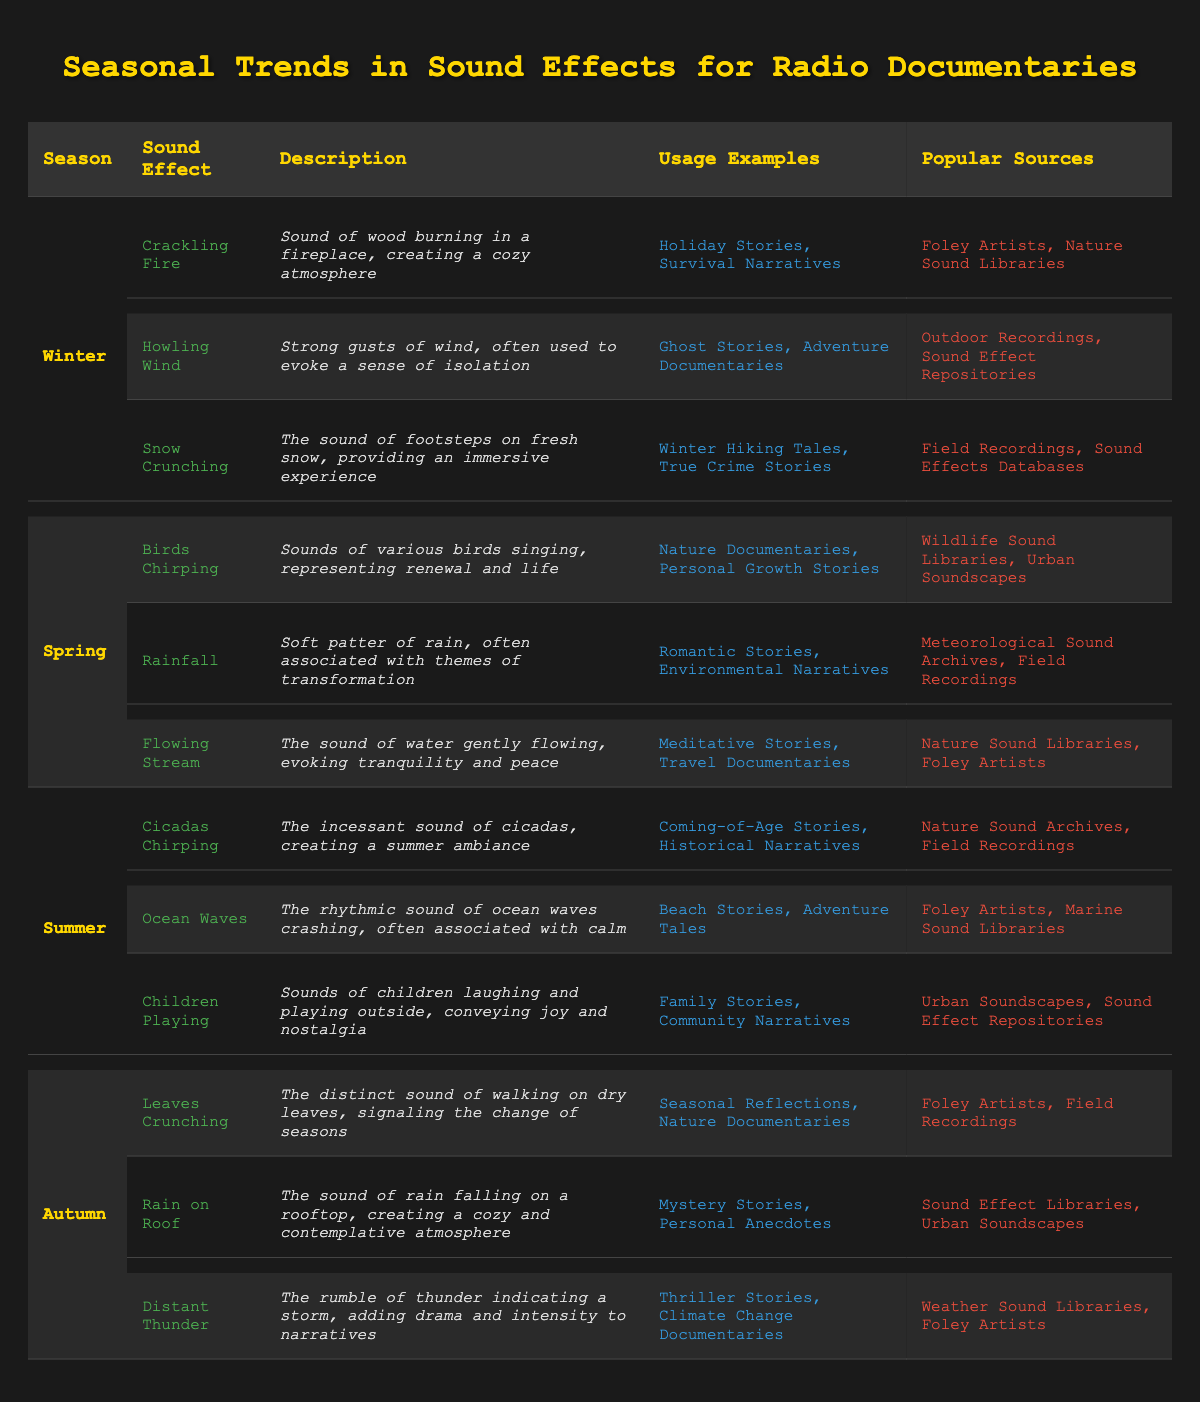What sound effects are associated with Winter? The table lists three sound effects for Winter: Crackling Fire, Howling Wind, and Snow Crunching.
Answer: Crackling Fire, Howling Wind, Snow Crunching Which season features "Cicadas Chirping" as a sound effect? The table indicates that "Cicadas Chirping" is listed under Summer as a sound effect.
Answer: Summer How many sound effects are used for Autumn? The table shows three sound effects for Autumn: Leaves Crunching, Rain on Roof, and Distant Thunder.
Answer: Three Is "Flowing Stream" used in Winter? Referring to the table, "Flowing Stream" is listed under Spring, indicating it is not a Winter sound effect.
Answer: No What are the popular sources for sound effects in Spring? The popular sources for Spring sound effects are Wildlife Sound Libraries and Urban Soundscapes, as shown in the table.
Answer: Wildlife Sound Libraries, Urban Soundscapes Identify the sound effect used in both Nature Documentaries and Travel Documentaries. The table shows that "Flowing Stream" is used in both Nature Documentaries and Travel Documentaries as indicated in the usage examples.
Answer: Flowing Stream How many sound effects do Foley Artists provide across all seasons? Foley Artists provide sound effects for Winter (3), Spring (1), Summer (1), and Autumn (2), totaling 7 sound effects. Therefore, the total is 3 + 1 + 1 + 2 = 7.
Answer: 7 Which season has the sound effect that evokes a sense of isolation? "Howling Wind," which evokes a sense of isolation, is listed under Winter in the table.
Answer: Winter Are there more sound effects related to Spring or Winter? There are three sound effects each for Winter and Spring according to the data in the table, so they are equal.
Answer: Equal What is the description of the sound effect "Distant Thunder"? The table describes "Distant Thunder" as the rumble of thunder indicating a storm, adding drama and intensity to narratives.
Answer: Rumble of thunder indicating a storm, adding drama and intensity 